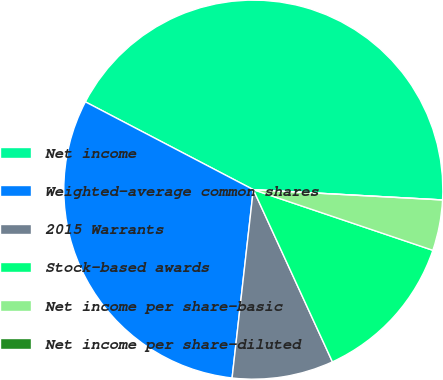Convert chart. <chart><loc_0><loc_0><loc_500><loc_500><pie_chart><fcel>Net income<fcel>Weighted-average common shares<fcel>2015 Warrants<fcel>Stock-based awards<fcel>Net income per share-basic<fcel>Net income per share-diluted<nl><fcel>43.2%<fcel>30.88%<fcel>8.64%<fcel>12.96%<fcel>4.32%<fcel>0.0%<nl></chart> 